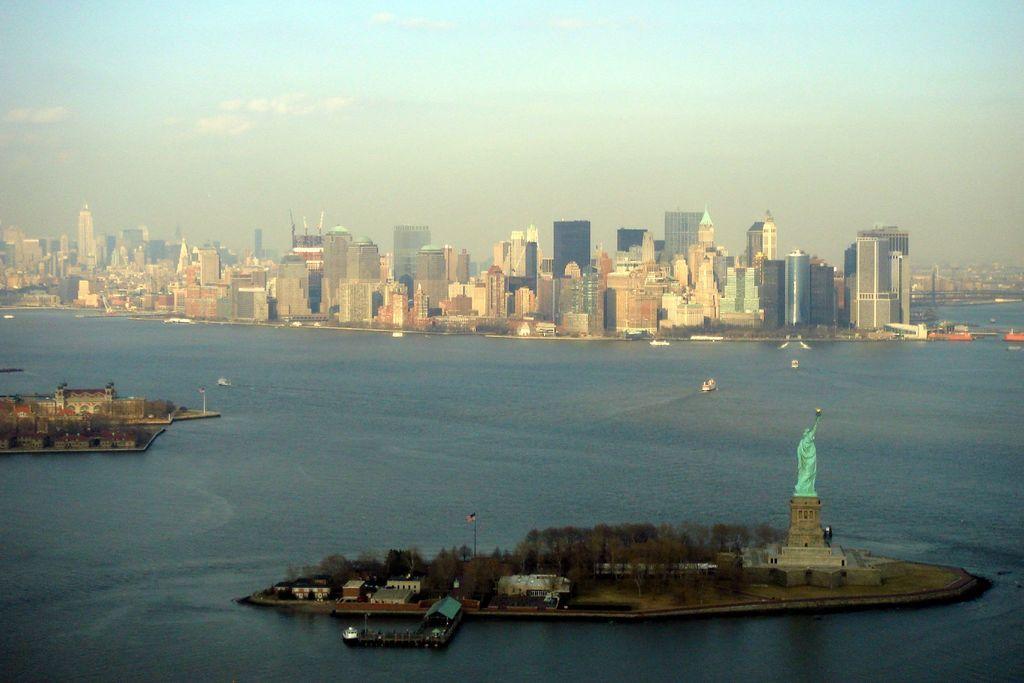In one or two sentences, can you explain what this image depicts? It is the image of New York city, beside the city there is a sea and in between the sea there is a sculpture of statue of liberty and few ships were sailing around the statue, there are many tall buildings and towers in the city. In the background there is sky. 